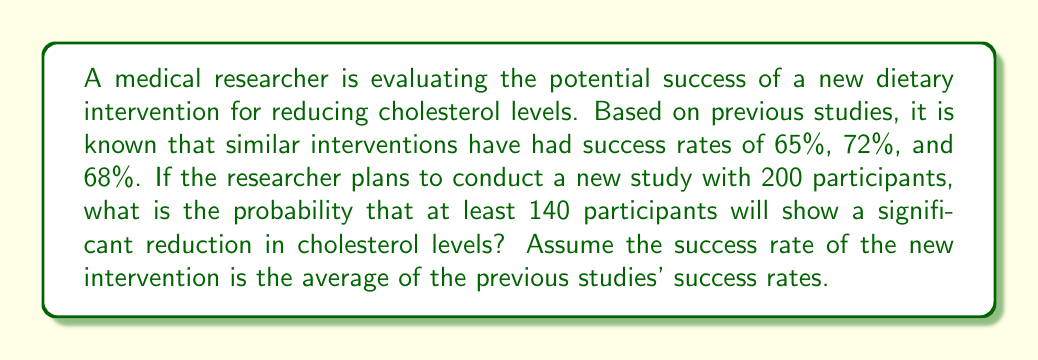Teach me how to tackle this problem. To solve this problem, we'll follow these steps:

1. Calculate the average success rate from previous studies:
   $$ \text{Average success rate} = \frac{65\% + 72\% + 68\%}{3} = \frac{205\%}{3} \approx 68.33\% $$

2. This problem follows a binomial distribution, where:
   - $n = 200$ (number of participants)
   - $p = 0.6833$ (probability of success for each participant)
   - We want to find $P(X \geq 140)$, where $X$ is the number of successful outcomes

3. The probability of at least 140 successes is equal to 1 minus the probability of 139 or fewer successes:
   $$ P(X \geq 140) = 1 - P(X \leq 139) $$

4. We can use the normal approximation to the binomial distribution since $np = 200 \times 0.6833 = 136.66$ and $nq = 200 \times (1-0.6833) = 63.34$ are both greater than 5.

5. Calculate the mean and standard deviation of the normal approximation:
   $$ \mu = np = 200 \times 0.6833 = 136.66 $$
   $$ \sigma = \sqrt{npq} = \sqrt{200 \times 0.6833 \times (1-0.6833)} = \sqrt{43.2822} \approx 6.58 $$

6. Calculate the z-score for 139.5 (using continuity correction):
   $$ z = \frac{139.5 - 136.66}{6.58} \approx 0.43 $$

7. Use a standard normal distribution table or calculator to find $P(Z \leq 0.43)$:
   $$ P(Z \leq 0.43) \approx 0.6664 $$

8. Calculate the final probability:
   $$ P(X \geq 140) = 1 - P(X \leq 139) \approx 1 - 0.6664 = 0.3336 $$
Answer: The probability that at least 140 out of 200 participants will show a significant reduction in cholesterol levels is approximately 0.3336 or 33.36%. 